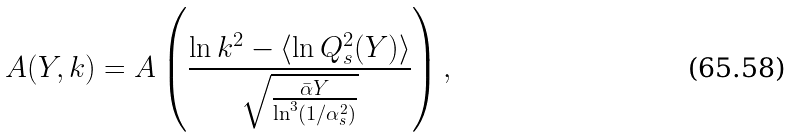<formula> <loc_0><loc_0><loc_500><loc_500>A ( Y , k ) = A \left ( \frac { \ln { k ^ { 2 } } - \langle \ln { Q _ { s } ^ { 2 } ( Y ) } \rangle } { \sqrt { \frac { \bar { \alpha } Y } { \ln ^ { 3 } ( 1 / \alpha _ { s } ^ { 2 } ) } } } \right ) ,</formula> 